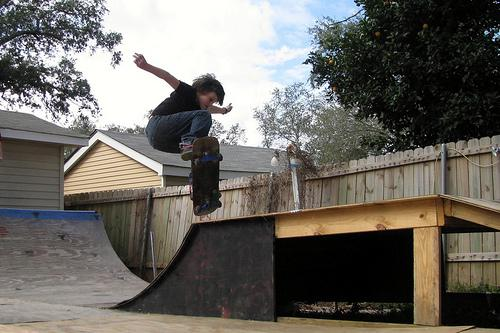Question: what is blue?
Choices:
A. Pants.
B. Sky.
C. Shirt.
D. Underwear.
Answer with the letter. Answer: B Question: who is in the air?
Choices:
A. Skier.
B. Snowboarder.
C. Hang glider.
D. Skateboarder.
Answer with the letter. Answer: D Question: where was the photo taken?
Choices:
A. By a home.
B. By a school.
C. In a backyard.
D. By a church.
Answer with the letter. Answer: C Question: what is green?
Choices:
A. Trees.
B. Bushes.
C. Leaves.
D. Water hose.
Answer with the letter. Answer: A Question: what is black?
Choices:
A. Boy's pants.
B. Boy's shirt.
C. Man's shorts.
D. Woman's blouse.
Answer with the letter. Answer: B 